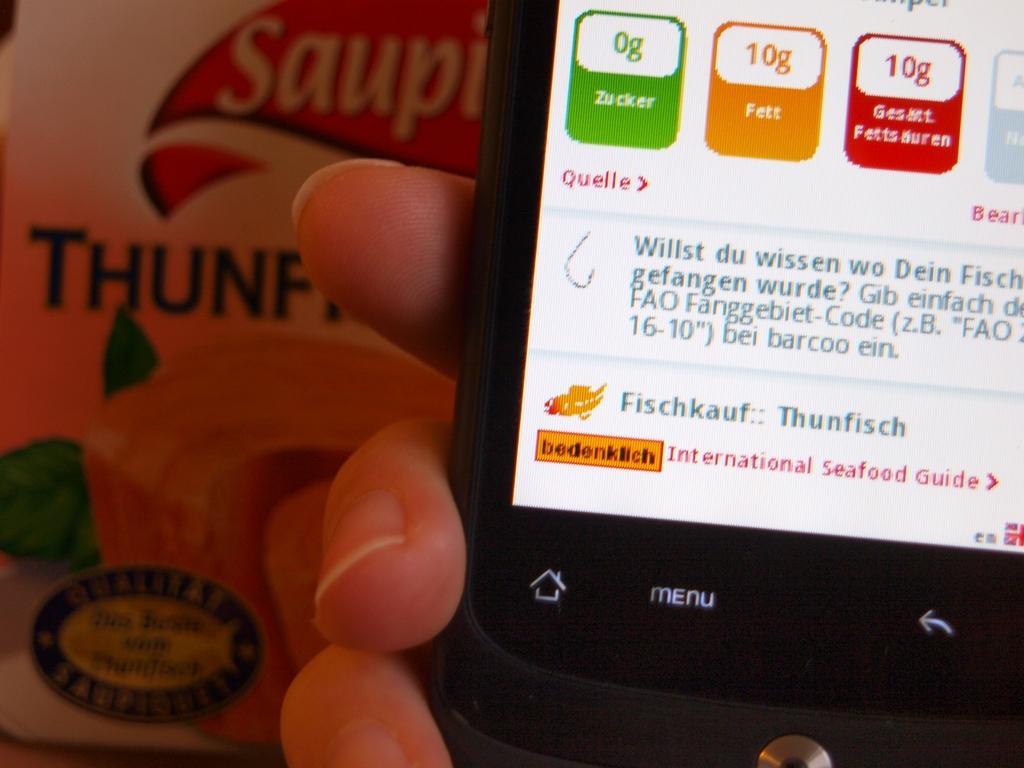<image>
Summarize the visual content of the image. A phone screen looking at the International Seafood Guide. 